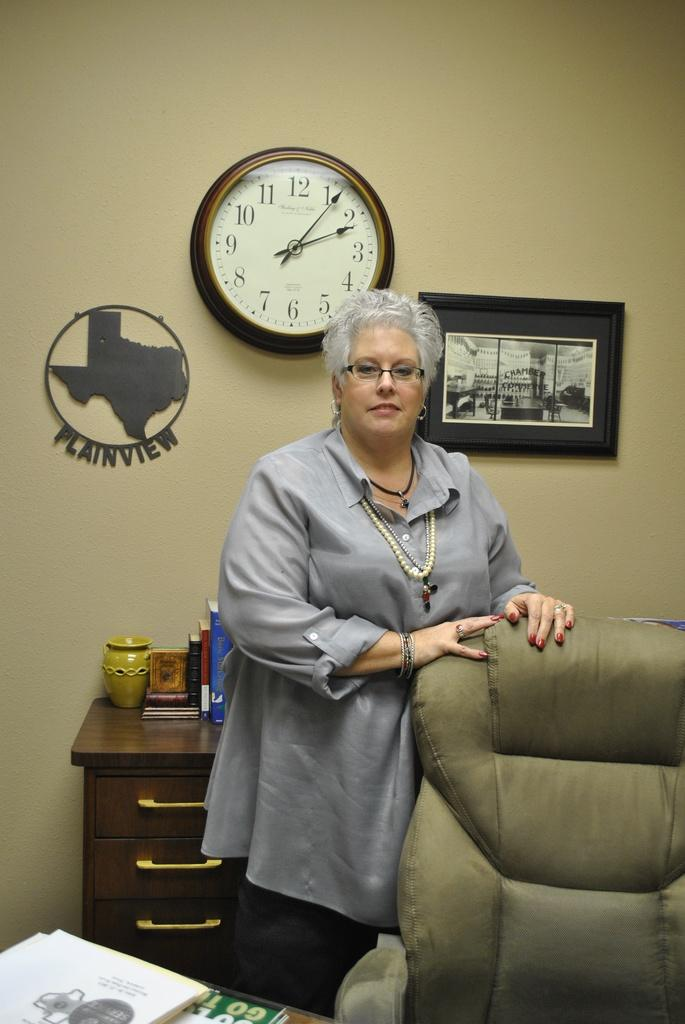Provide a one-sentence caption for the provided image. A woman stands in front of a plaque of Plainview and the state of Texas. 